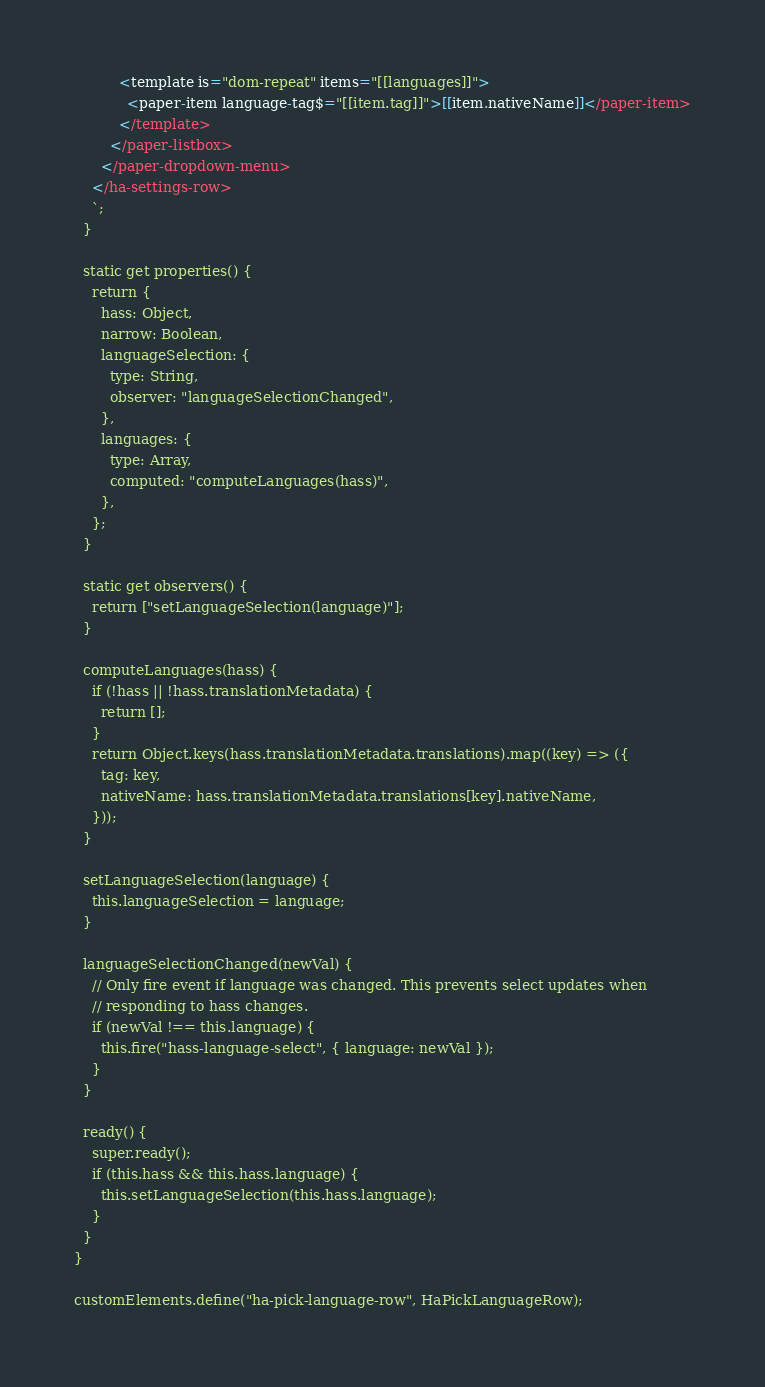Convert code to text. <code><loc_0><loc_0><loc_500><loc_500><_JavaScript_>          <template is="dom-repeat" items="[[languages]]">
            <paper-item language-tag$="[[item.tag]]">[[item.nativeName]]</paper-item>
          </template>
        </paper-listbox>
      </paper-dropdown-menu>
    </ha-settings-row>
    `;
  }

  static get properties() {
    return {
      hass: Object,
      narrow: Boolean,
      languageSelection: {
        type: String,
        observer: "languageSelectionChanged",
      },
      languages: {
        type: Array,
        computed: "computeLanguages(hass)",
      },
    };
  }

  static get observers() {
    return ["setLanguageSelection(language)"];
  }

  computeLanguages(hass) {
    if (!hass || !hass.translationMetadata) {
      return [];
    }
    return Object.keys(hass.translationMetadata.translations).map((key) => ({
      tag: key,
      nativeName: hass.translationMetadata.translations[key].nativeName,
    }));
  }

  setLanguageSelection(language) {
    this.languageSelection = language;
  }

  languageSelectionChanged(newVal) {
    // Only fire event if language was changed. This prevents select updates when
    // responding to hass changes.
    if (newVal !== this.language) {
      this.fire("hass-language-select", { language: newVal });
    }
  }

  ready() {
    super.ready();
    if (this.hass && this.hass.language) {
      this.setLanguageSelection(this.hass.language);
    }
  }
}

customElements.define("ha-pick-language-row", HaPickLanguageRow);
</code> 